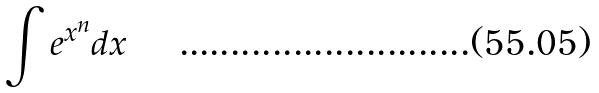Convert formula to latex. <formula><loc_0><loc_0><loc_500><loc_500>\int e ^ { x ^ { n } } d x</formula> 